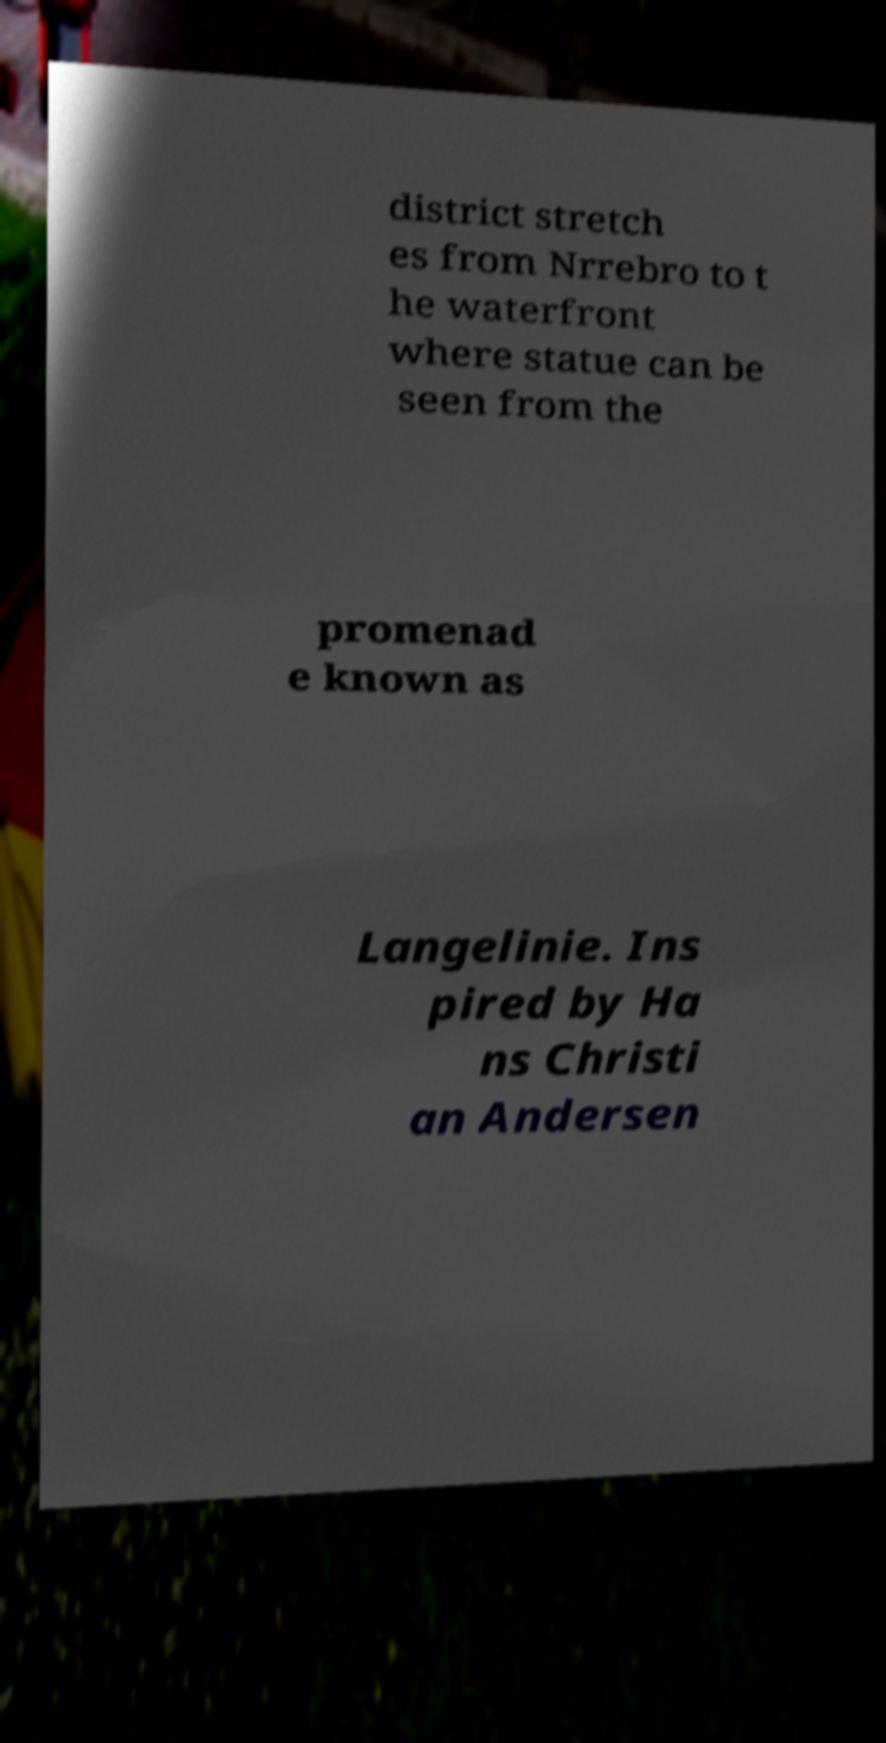Can you read and provide the text displayed in the image?This photo seems to have some interesting text. Can you extract and type it out for me? district stretch es from Nrrebro to t he waterfront where statue can be seen from the promenad e known as Langelinie. Ins pired by Ha ns Christi an Andersen 